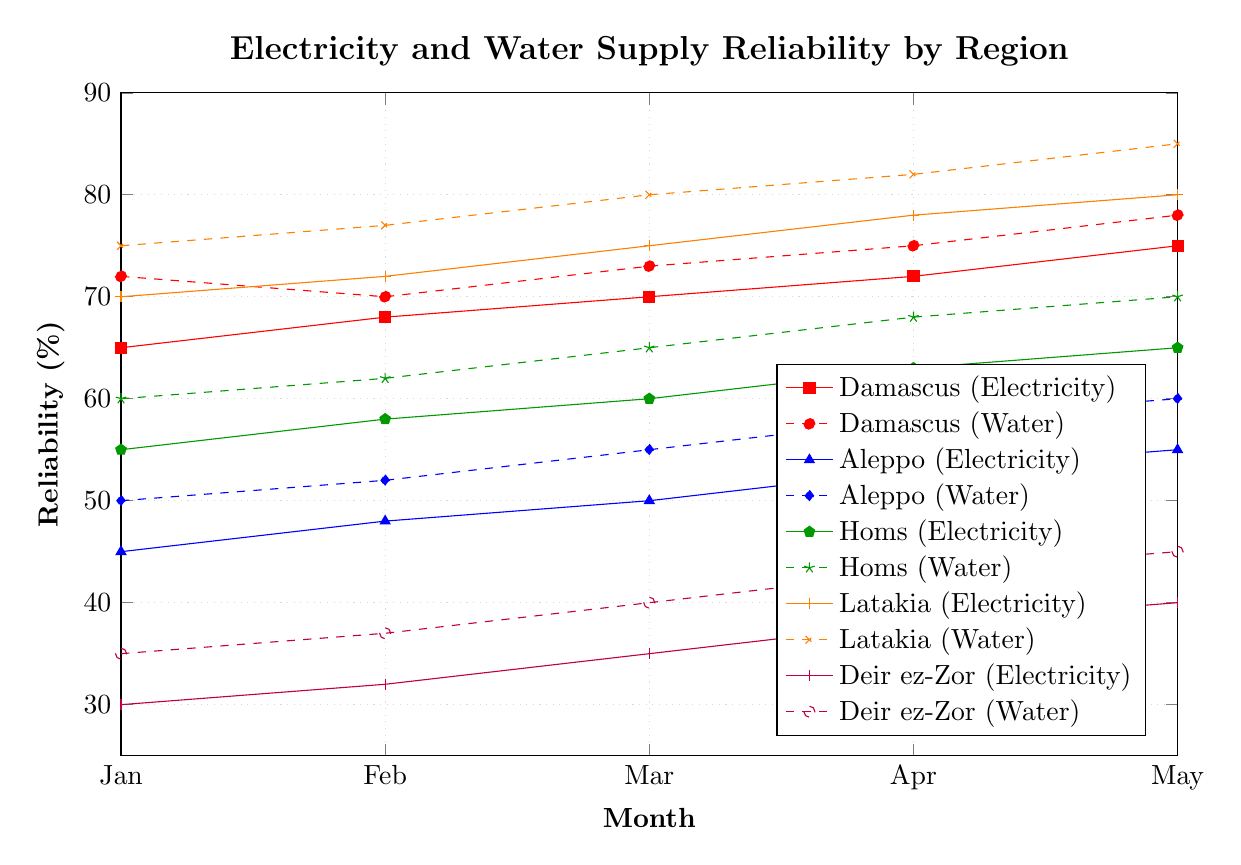What is the maximum value for water supply reliability in Latakia? Look at the plot for Latakia (water) which uses an orange dashed line. The maximum point on the y-axis for this line is at May (85%).
Answer: 85 Which region has the lowest electricity reliability in January? Refer to the lines representing electricity reliability for all regions in January. The lowest starting point is for Deir ez-Zor (30%).
Answer: Deir ez-Zor Between Damascus and Aleppo, which region showed a greater overall improvement in water supply reliability from January to May? Calculate the difference in water reliability values for January and May for both regions. Damascus: 78% - 72% = 6%, Aleppo: 60% - 50% = 10%. Aleppo has a greater improvement.
Answer: Aleppo By how many percentage points did electricity reliability in Homs increase from February to March? Compare the electricity reliability for Homs in February (58%) and March (60%). The difference is 60% - 58% = 2%.
Answer: 2 Which month did water supply reliability in Damascus surpass 75%? Check the points along the Damascus (water) line. The value surpasses 75% between April (75%) and May (78%).
Answer: May What is the average electricity reliability for Aleppo from January to May? Sum the electricity reliability values for Aleppo from January to May (45% + 48% + 50% + 53% + 55%) and divide by 5. Average = (45 + 48 + 50 + 53 + 55) / 5 = 50.2%.
Answer: 50.2 Which region had the highest water supply reliability in March? Look at all the points for March in the water supply reliability lines. Latakia has the highest value at 80%.
Answer: Latakia How did the water supply reliability in Deir ez-Zor change from January to April? Look at the water supply line for Deir ez-Zor from January (35%) to April (43%). Calculate the difference: 43% - 35% = 8%.
Answer: Increased by 8% Is the electricity reliability in Damascus ever higher than the water supply reliability in Latakia from January to May? Compare the lines for Damascus (electricity) and Latakia (water) across all months. Latakia's water reliability is consistently higher than Damascus' electricity reliability across all months.
Answer: No What is the difference in water supply reliability between Latakia and Deir ez-Zor in May? Refer to the water reliability in May for Latakia (85%) and Deir ez-Zor (45%). Calculate the difference: 85% - 45% = 40%.
Answer: 40 